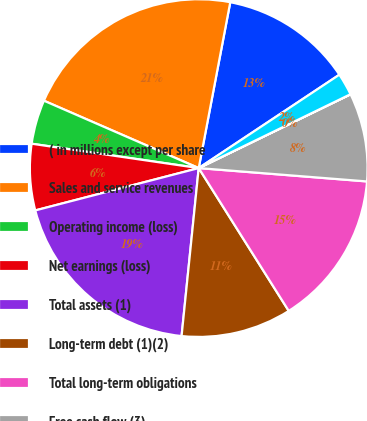Convert chart. <chart><loc_0><loc_0><loc_500><loc_500><pie_chart><fcel>( in millions except per share<fcel>Sales and service revenues<fcel>Operating income (loss)<fcel>Net earnings (loss)<fcel>Total assets (1)<fcel>Long-term debt (1)(2)<fcel>Total long-term obligations<fcel>Free cash flow (3)<fcel>Basic earnings (loss) per<fcel>Diluted earnings (loss) per<nl><fcel>12.68%<fcel>21.46%<fcel>4.23%<fcel>6.34%<fcel>19.35%<fcel>10.57%<fcel>14.79%<fcel>8.46%<fcel>0.01%<fcel>2.12%<nl></chart> 